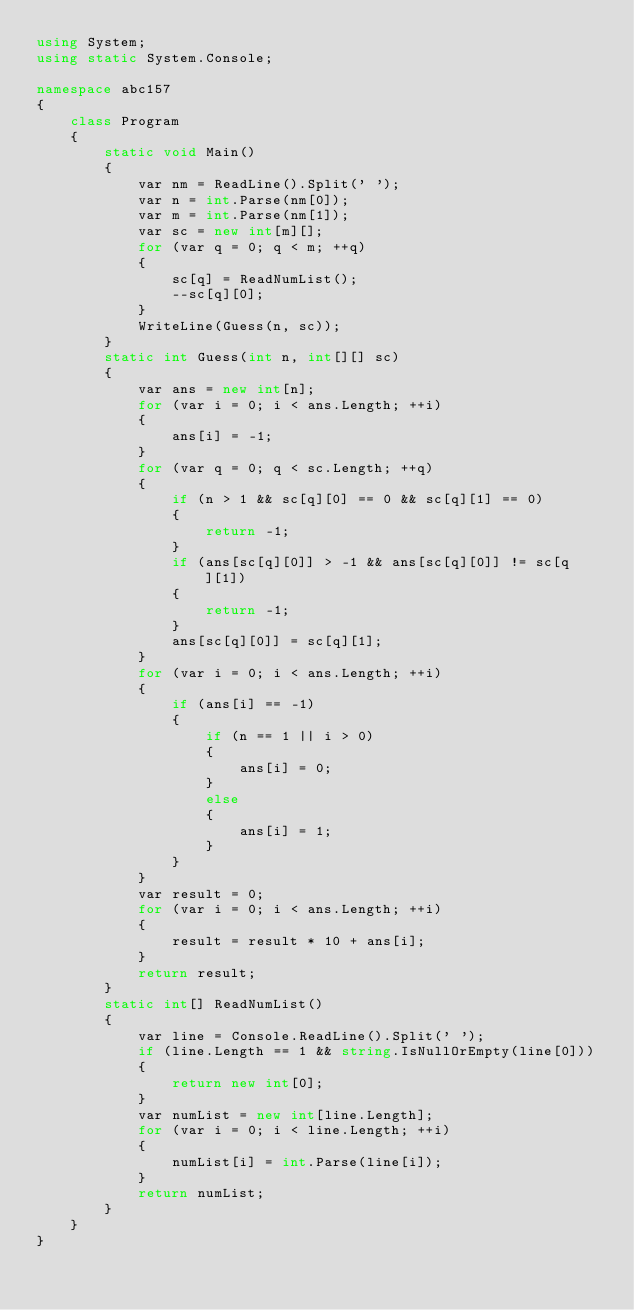<code> <loc_0><loc_0><loc_500><loc_500><_C#_>using System;
using static System.Console;

namespace abc157
{
    class Program
    {
        static void Main()
        {
            var nm = ReadLine().Split(' ');
            var n = int.Parse(nm[0]);
            var m = int.Parse(nm[1]);
            var sc = new int[m][];
            for (var q = 0; q < m; ++q)
            {
                sc[q] = ReadNumList();
                --sc[q][0];
            }
            WriteLine(Guess(n, sc));
        }
        static int Guess(int n, int[][] sc)
        {
            var ans = new int[n];
            for (var i = 0; i < ans.Length; ++i)
            {
                ans[i] = -1;
            }
            for (var q = 0; q < sc.Length; ++q)
            {
                if (n > 1 && sc[q][0] == 0 && sc[q][1] == 0)
                {
                    return -1;
                }
                if (ans[sc[q][0]] > -1 && ans[sc[q][0]] != sc[q][1])
                {
                    return -1;
                }
                ans[sc[q][0]] = sc[q][1];
            }
            for (var i = 0; i < ans.Length; ++i)
            {
                if (ans[i] == -1)
                {
                    if (n == 1 || i > 0)
                    {
                        ans[i] = 0;
                    }
                    else
                    {
                        ans[i] = 1;
                    }
                }
            }
            var result = 0;
            for (var i = 0; i < ans.Length; ++i)
            {
                result = result * 10 + ans[i];
            }
            return result;
        }
        static int[] ReadNumList()
        {
            var line = Console.ReadLine().Split(' ');
            if (line.Length == 1 && string.IsNullOrEmpty(line[0]))
            {
                return new int[0];
            }
            var numList = new int[line.Length];
            for (var i = 0; i < line.Length; ++i)
            {
                numList[i] = int.Parse(line[i]);
            }
            return numList;
        }
    }
}
</code> 